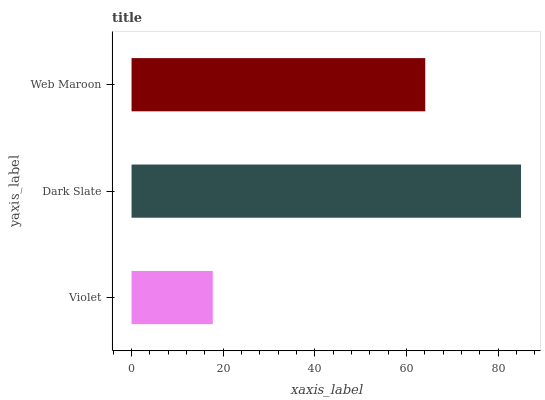Is Violet the minimum?
Answer yes or no. Yes. Is Dark Slate the maximum?
Answer yes or no. Yes. Is Web Maroon the minimum?
Answer yes or no. No. Is Web Maroon the maximum?
Answer yes or no. No. Is Dark Slate greater than Web Maroon?
Answer yes or no. Yes. Is Web Maroon less than Dark Slate?
Answer yes or no. Yes. Is Web Maroon greater than Dark Slate?
Answer yes or no. No. Is Dark Slate less than Web Maroon?
Answer yes or no. No. Is Web Maroon the high median?
Answer yes or no. Yes. Is Web Maroon the low median?
Answer yes or no. Yes. Is Dark Slate the high median?
Answer yes or no. No. Is Dark Slate the low median?
Answer yes or no. No. 